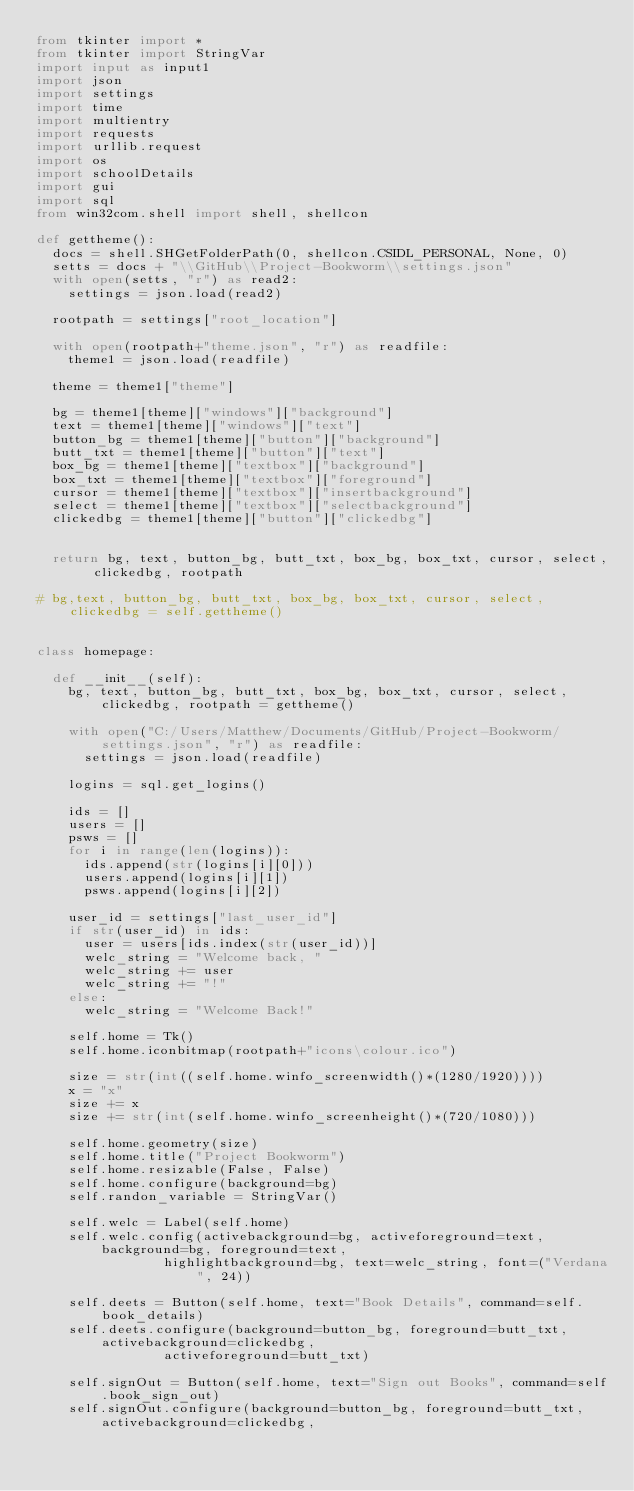<code> <loc_0><loc_0><loc_500><loc_500><_Python_>from tkinter import *
from tkinter import StringVar
import input as input1
import json
import settings
import time
import multientry
import requests
import urllib.request
import os
import schoolDetails
import gui
import sql
from win32com.shell import shell, shellcon

def gettheme():
	docs = shell.SHGetFolderPath(0, shellcon.CSIDL_PERSONAL, None, 0)
	setts = docs + "\\GitHub\\Project-Bookworm\\settings.json"
	with open(setts, "r") as read2:
		settings = json.load(read2)

	rootpath = settings["root_location"]

	with open(rootpath+"theme.json", "r") as readfile:
		theme1 = json.load(readfile)

	theme = theme1["theme"]

	bg = theme1[theme]["windows"]["background"]
	text = theme1[theme]["windows"]["text"]
	button_bg = theme1[theme]["button"]["background"]
	butt_txt = theme1[theme]["button"]["text"]
	box_bg = theme1[theme]["textbox"]["background"]
	box_txt = theme1[theme]["textbox"]["foreground"]
	cursor = theme1[theme]["textbox"]["insertbackground"]
	select = theme1[theme]["textbox"]["selectbackground"]
	clickedbg = theme1[theme]["button"]["clickedbg"]


	return bg, text, button_bg, butt_txt, box_bg, box_txt, cursor, select, clickedbg, rootpath

# bg,text, button_bg, butt_txt, box_bg, box_txt, cursor, select, clickedbg = self.gettheme()


class homepage:

	def __init__(self):
		bg, text, button_bg, butt_txt, box_bg, box_txt, cursor, select, clickedbg, rootpath = gettheme()

		with open("C:/Users/Matthew/Documents/GitHub/Project-Bookworm/settings.json", "r") as readfile:
			settings = json.load(readfile)

		logins = sql.get_logins()

		ids = []
		users = []
		psws = []
		for i in range(len(logins)):
			ids.append(str(logins[i][0]))
			users.append(logins[i][1])
			psws.append(logins[i][2])

		user_id = settings["last_user_id"]
		if str(user_id) in ids:
			user = users[ids.index(str(user_id))]
			welc_string = "Welcome back, "
			welc_string += user
			welc_string += "!"
		else:
			welc_string = "Welcome Back!"

		self.home = Tk()
		self.home.iconbitmap(rootpath+"icons\colour.ico")

		size = str(int((self.home.winfo_screenwidth()*(1280/1920))))
		x = "x"
		size += x
		size += str(int(self.home.winfo_screenheight()*(720/1080)))

		self.home.geometry(size)
		self.home.title("Project Bookworm")
		self.home.resizable(False, False)
		self.home.configure(background=bg)
		self.randon_variable = StringVar()

		self.welc = Label(self.home)
		self.welc.config(activebackground=bg, activeforeground=text, background=bg, foreground=text,
								highlightbackground=bg, text=welc_string, font=("Verdana", 24))

		self.deets = Button(self.home, text="Book Details", command=self.book_details)
		self.deets.configure(background=button_bg, foreground=butt_txt, activebackground=clickedbg,
								activeforeground=butt_txt)

		self.signOut = Button(self.home, text="Sign out Books", command=self.book_sign_out)
		self.signOut.configure(background=button_bg, foreground=butt_txt, activebackground=clickedbg,</code> 